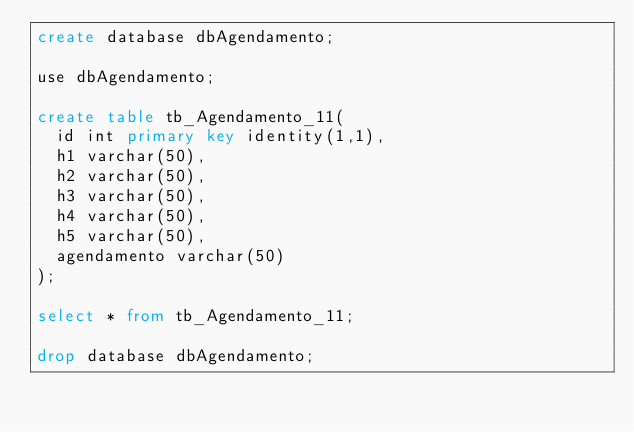<code> <loc_0><loc_0><loc_500><loc_500><_SQL_>create database dbAgendamento;

use dbAgendamento;

create table tb_Agendamento_11(
	id int primary key identity(1,1),
	h1 varchar(50),
	h2 varchar(50),
	h3 varchar(50),
	h4 varchar(50),
	h5 varchar(50),
	agendamento varchar(50)
);

select * from tb_Agendamento_11;

drop database dbAgendamento;
</code> 